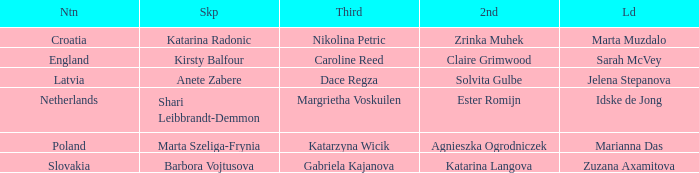Which Lead has Katarina Radonic as Skip? Marta Muzdalo. 